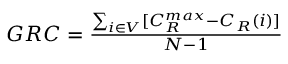<formula> <loc_0><loc_0><loc_500><loc_500>\begin{array} { r } { G R C = \frac { \sum _ { i \in V } [ C _ { R } ^ { \max } - C _ { R } ( i ) ] } { N - 1 } } \end{array}</formula> 